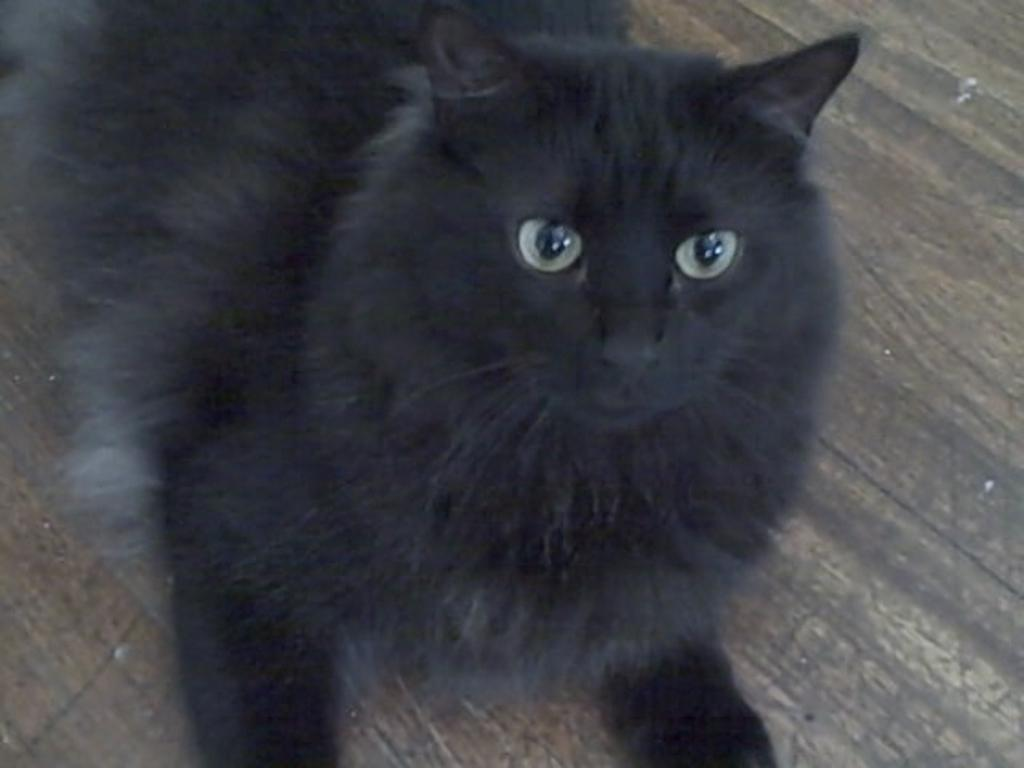What type of animal is in the image? There is a black cat in the image. What is the cat standing or sitting on? The cat is present on a wooden surface. Can you find the receipt for the cat's purchase in the image? There is no receipt present in the image, as it only features a black cat on a wooden surface. 